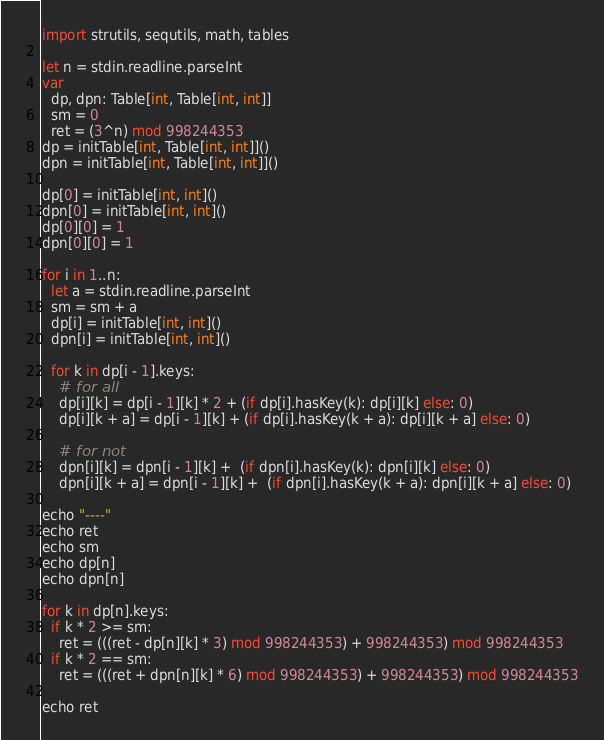<code> <loc_0><loc_0><loc_500><loc_500><_Nim_>import strutils, sequtils, math, tables

let n = stdin.readline.parseInt
var
  dp, dpn: Table[int, Table[int, int]]
  sm = 0
  ret = (3^n) mod 998244353
dp = initTable[int, Table[int, int]]()
dpn = initTable[int, Table[int, int]]()

dp[0] = initTable[int, int]()
dpn[0] = initTable[int, int]()
dp[0][0] = 1
dpn[0][0] = 1

for i in 1..n:
  let a = stdin.readline.parseInt
  sm = sm + a
  dp[i] = initTable[int, int]()
  dpn[i] = initTable[int, int]()

  for k in dp[i - 1].keys:
    # for all
    dp[i][k] = dp[i - 1][k] * 2 + (if dp[i].hasKey(k): dp[i][k] else: 0)
    dp[i][k + a] = dp[i - 1][k] + (if dp[i].hasKey(k + a): dp[i][k + a] else: 0)

    # for not
    dpn[i][k] = dpn[i - 1][k] +  (if dpn[i].hasKey(k): dpn[i][k] else: 0)
    dpn[i][k + a] = dpn[i - 1][k] +  (if dpn[i].hasKey(k + a): dpn[i][k + a] else: 0)

echo "----"
echo ret
echo sm
echo dp[n]
echo dpn[n]

for k in dp[n].keys:
  if k * 2 >= sm:
    ret = (((ret - dp[n][k] * 3) mod 998244353) + 998244353) mod 998244353
  if k * 2 == sm:
    ret = (((ret + dpn[n][k] * 6) mod 998244353) + 998244353) mod 998244353

echo ret
</code> 